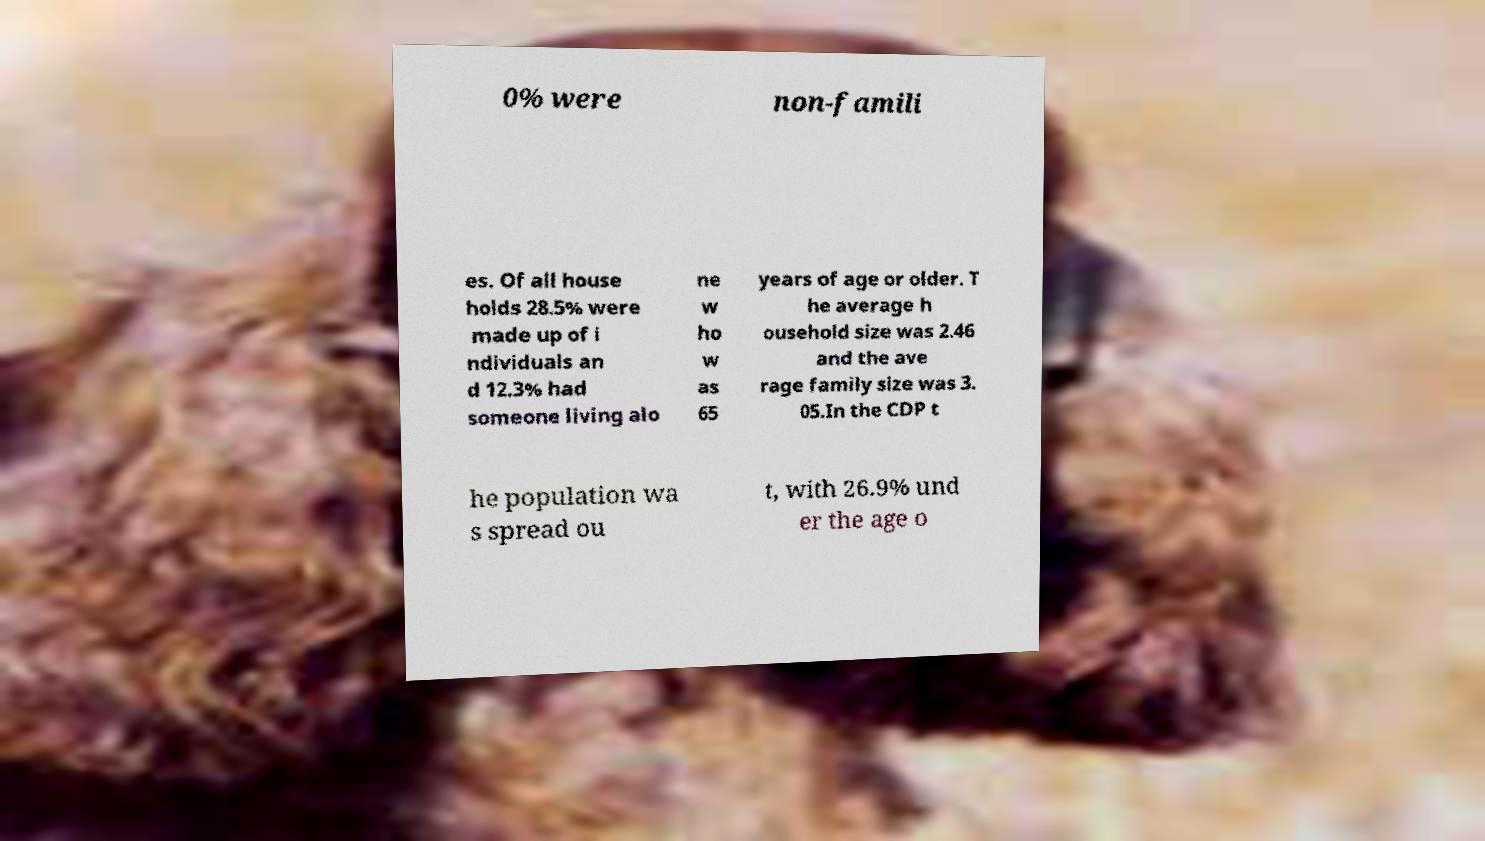Can you read and provide the text displayed in the image?This photo seems to have some interesting text. Can you extract and type it out for me? 0% were non-famili es. Of all house holds 28.5% were made up of i ndividuals an d 12.3% had someone living alo ne w ho w as 65 years of age or older. T he average h ousehold size was 2.46 and the ave rage family size was 3. 05.In the CDP t he population wa s spread ou t, with 26.9% und er the age o 